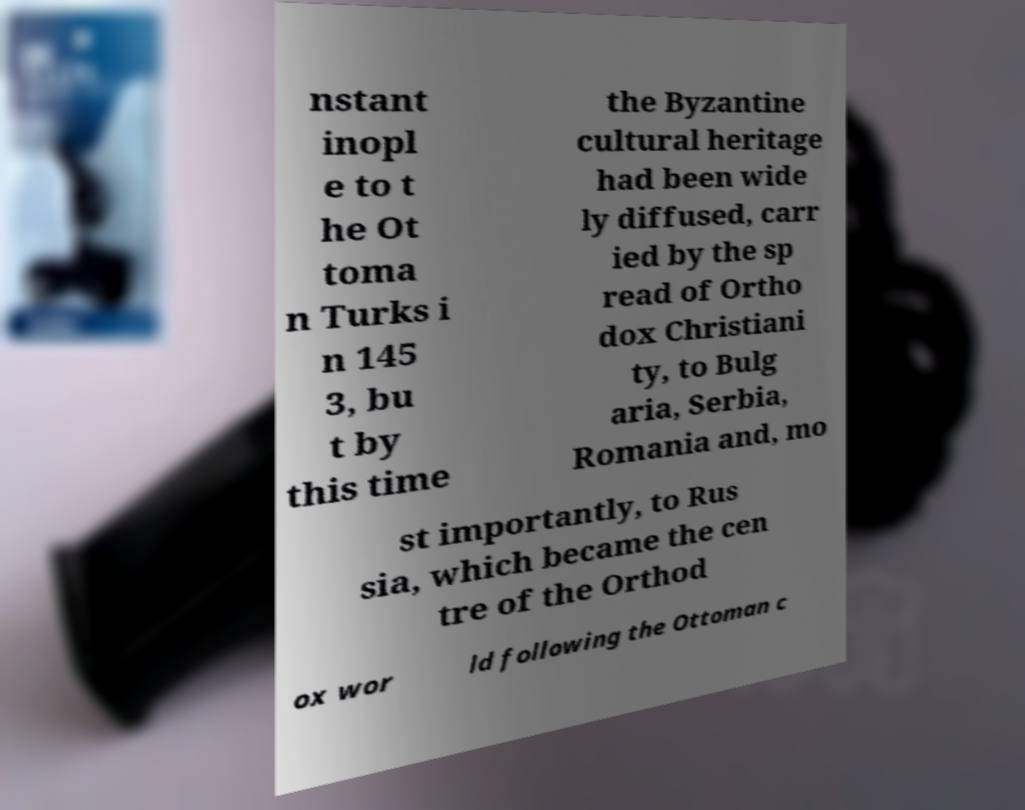Could you extract and type out the text from this image? nstant inopl e to t he Ot toma n Turks i n 145 3, bu t by this time the Byzantine cultural heritage had been wide ly diffused, carr ied by the sp read of Ortho dox Christiani ty, to Bulg aria, Serbia, Romania and, mo st importantly, to Rus sia, which became the cen tre of the Orthod ox wor ld following the Ottoman c 